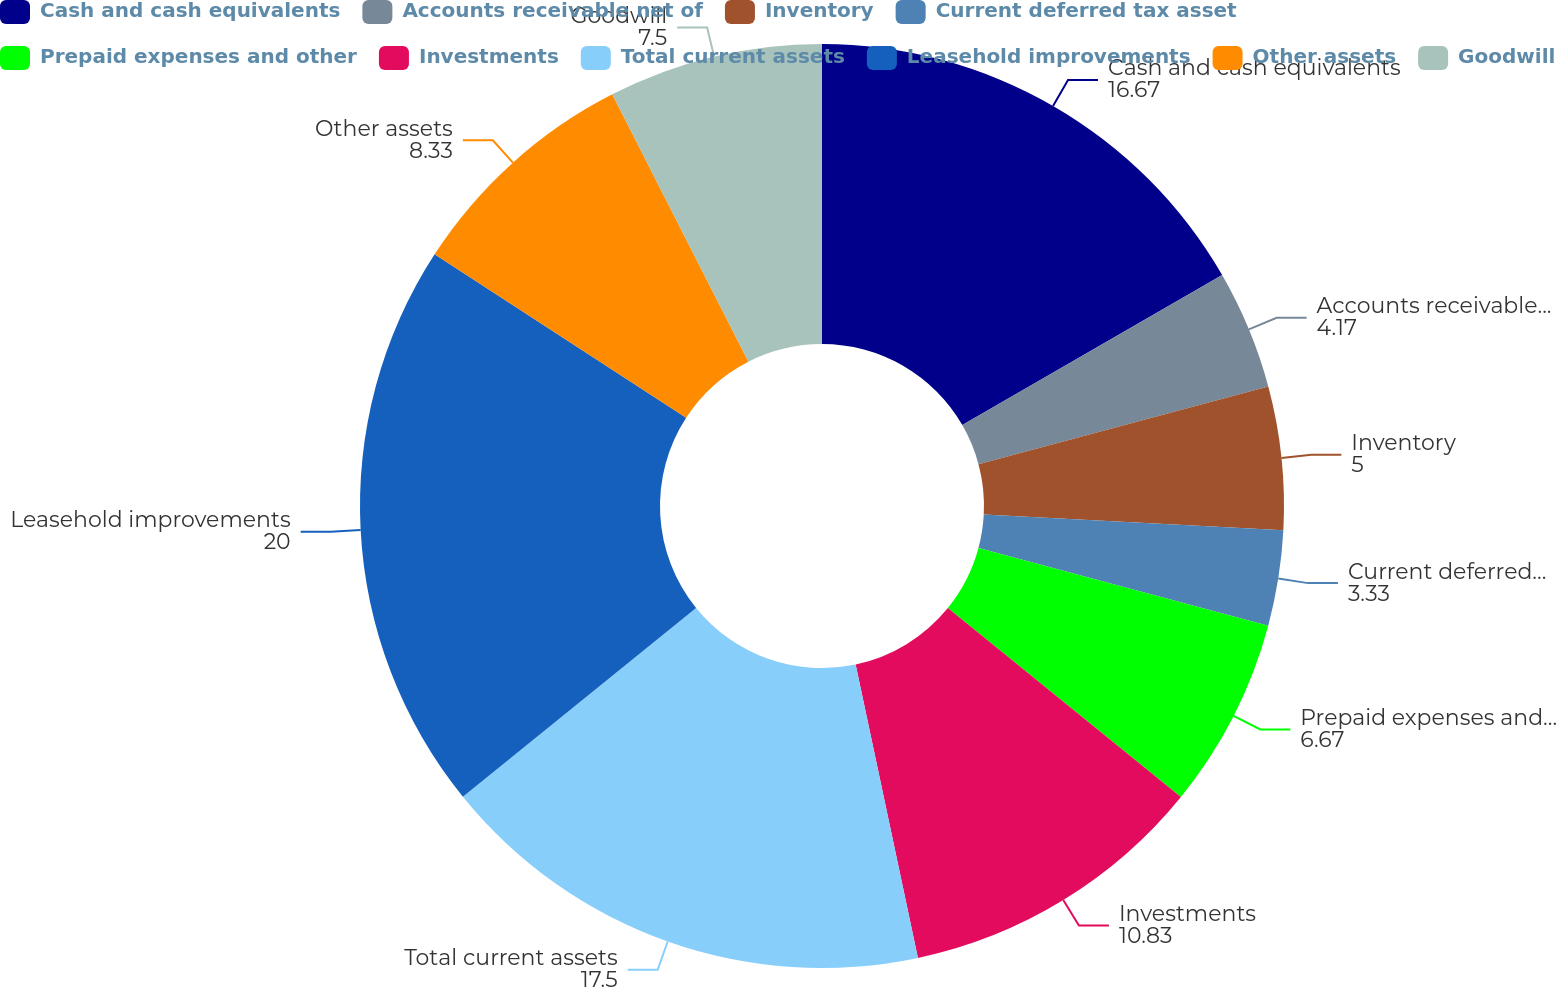<chart> <loc_0><loc_0><loc_500><loc_500><pie_chart><fcel>Cash and cash equivalents<fcel>Accounts receivable net of<fcel>Inventory<fcel>Current deferred tax asset<fcel>Prepaid expenses and other<fcel>Investments<fcel>Total current assets<fcel>Leasehold improvements<fcel>Other assets<fcel>Goodwill<nl><fcel>16.67%<fcel>4.17%<fcel>5.0%<fcel>3.33%<fcel>6.67%<fcel>10.83%<fcel>17.5%<fcel>20.0%<fcel>8.33%<fcel>7.5%<nl></chart> 